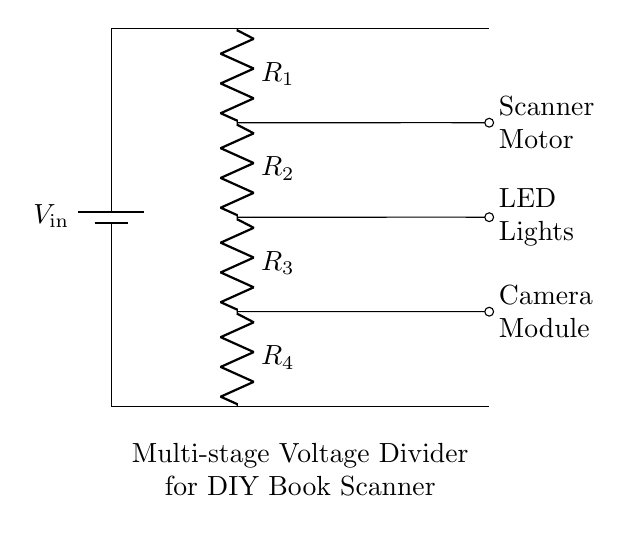What is the input voltage of the circuit? The input voltage is labeled as V_in at the top of the circuit diagram. It is generally the voltage provided to the entire voltage divider.
Answer: V_in How many resistors are used in the voltage divider? The circuit diagram shows a total of four resistors: R_1, R_2, R_3, and R_4. Each one is designated in the drawing, indicating their presence and connection in the circuit.
Answer: Four What component powers the scanner motor? The scanner motor is directly connected to the output from R_1, which provides power derived from the voltage divider. The connection is indicated by the line going to the right from R_1.
Answer: Scanner Motor What happens to the voltages across the resistors in a voltage divider? The voltage across each resistor is proportional to its resistance value and the total voltage. The configuration reduces the voltage gradually across the series resistors, which allows for different levels of voltage for connected components.
Answer: Voltage drop What determines the voltage for the camera module? The camera module is connected to the output of R_3, which means its voltage depends on the total input voltage and the values of R_1, R_2, and R_3 in relation to the total resistance. This forms part of the voltage division process.
Answer: R_1, R_2, R_3 What is the role of the resistors in this circuit? Resistors in a voltage divider control the distribution of voltage across their series connection, allowing for specific voltages needed by various components. Their values determine how much voltage each component receives based on Ohm's law.
Answer: Voltage division 